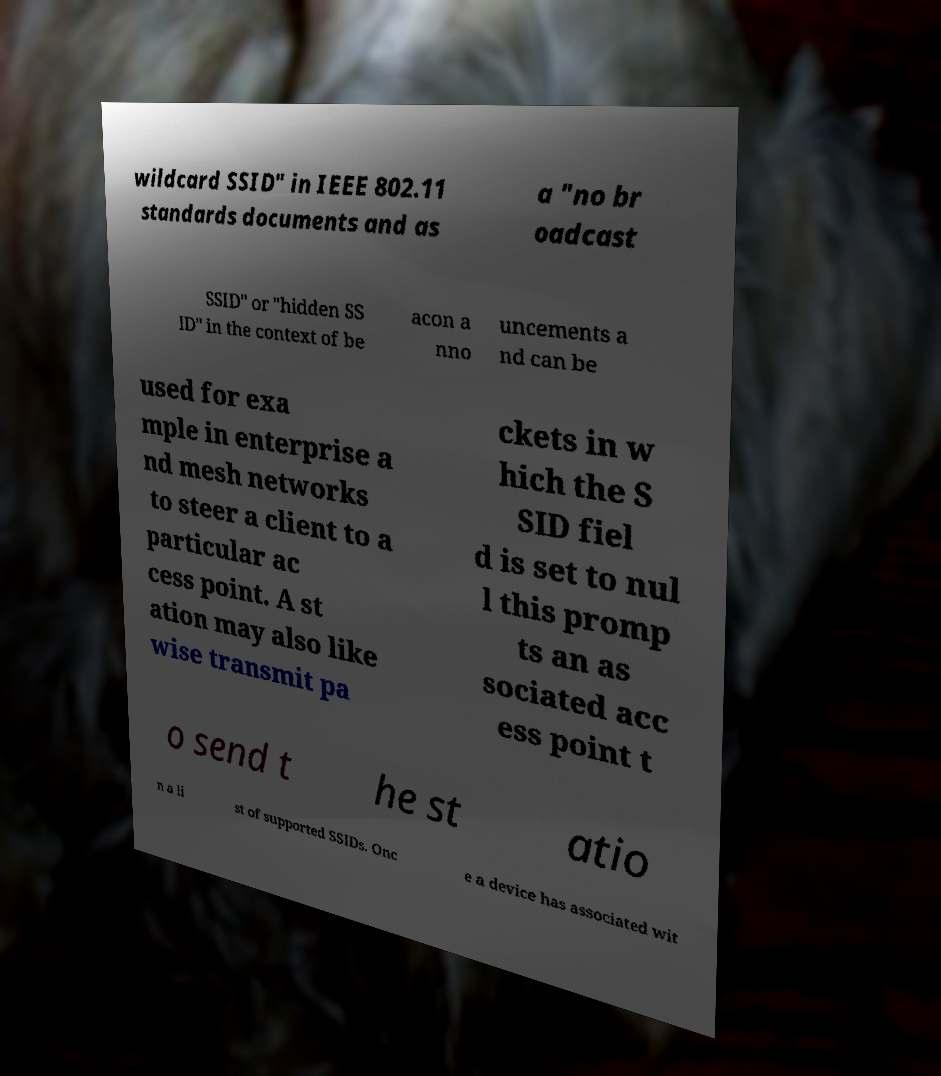There's text embedded in this image that I need extracted. Can you transcribe it verbatim? wildcard SSID" in IEEE 802.11 standards documents and as a "no br oadcast SSID" or "hidden SS ID" in the context of be acon a nno uncements a nd can be used for exa mple in enterprise a nd mesh networks to steer a client to a particular ac cess point. A st ation may also like wise transmit pa ckets in w hich the S SID fiel d is set to nul l this promp ts an as sociated acc ess point t o send t he st atio n a li st of supported SSIDs. Onc e a device has associated wit 